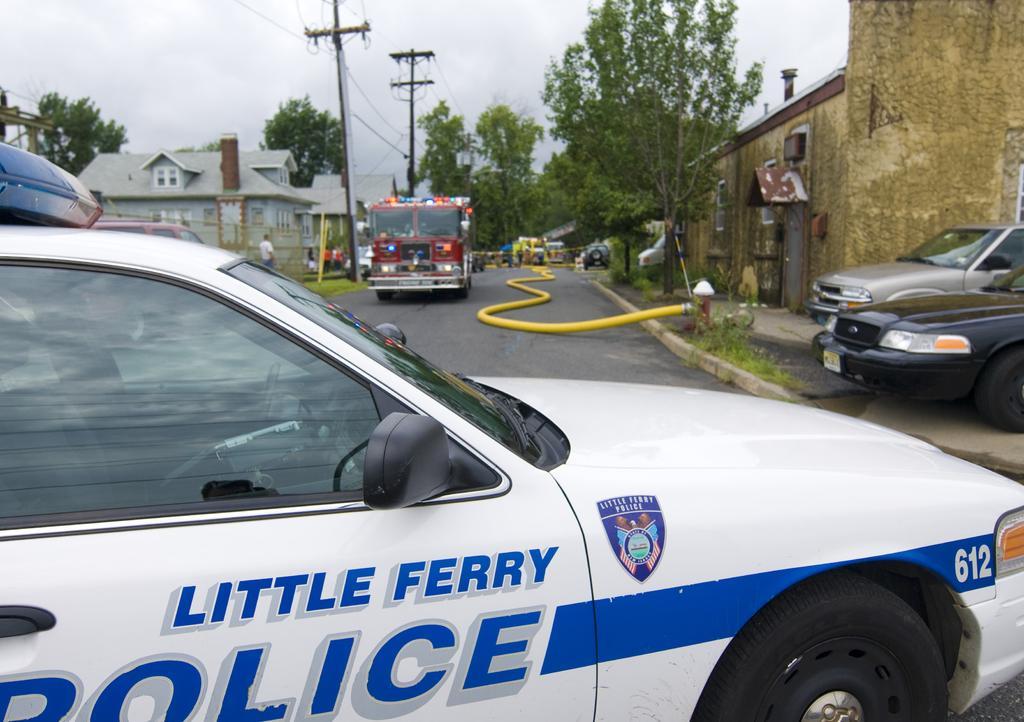Describe this image in one or two sentences. In this picture we can see vehicles on the road with trees, houses and electric poles on either side. Here we can also see a tap with a water pipe on the right side. 